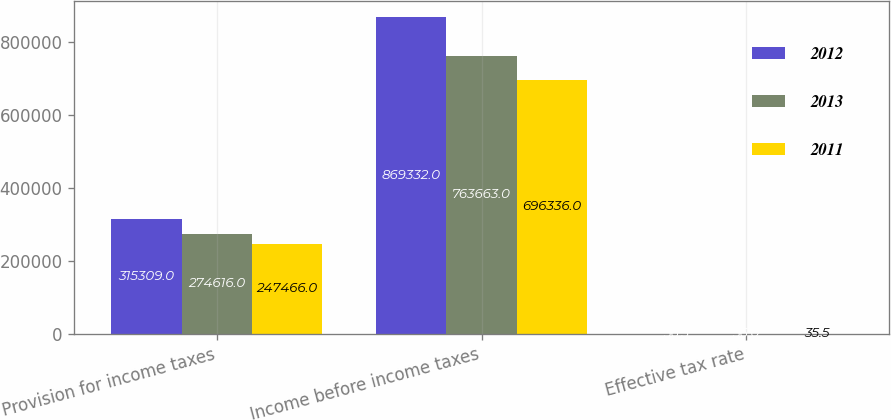Convert chart. <chart><loc_0><loc_0><loc_500><loc_500><stacked_bar_chart><ecel><fcel>Provision for income taxes<fcel>Income before income taxes<fcel>Effective tax rate<nl><fcel>2012<fcel>315309<fcel>869332<fcel>36.3<nl><fcel>2013<fcel>274616<fcel>763663<fcel>36<nl><fcel>2011<fcel>247466<fcel>696336<fcel>35.5<nl></chart> 